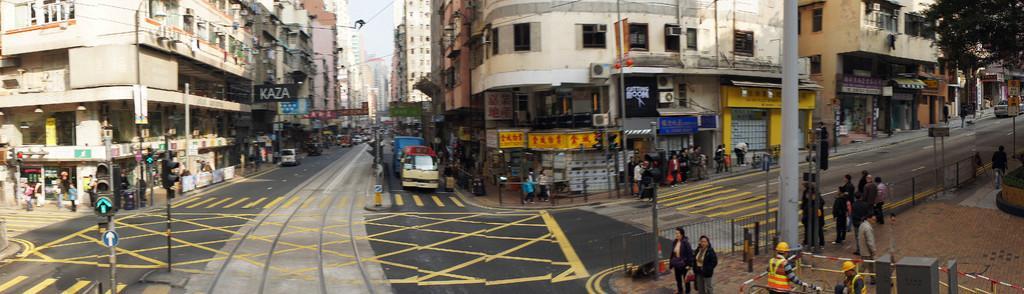Please provide a concise description of this image. The picture is taken outside a city. On the right there are poles, sign boards, railing, footpath, trees, buildings, car and people. In the center of the picture there are people buildings, poles, vehicles, hoardings, railing and road. On the left there are building, hoardings, signal light ,road and vehicles. In the center of the background there are buildings and vehicles. It is sunny. 